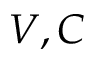Convert formula to latex. <formula><loc_0><loc_0><loc_500><loc_500>V , C</formula> 